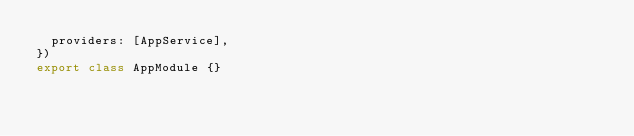Convert code to text. <code><loc_0><loc_0><loc_500><loc_500><_TypeScript_>  providers: [AppService],
})
export class AppModule {}
</code> 